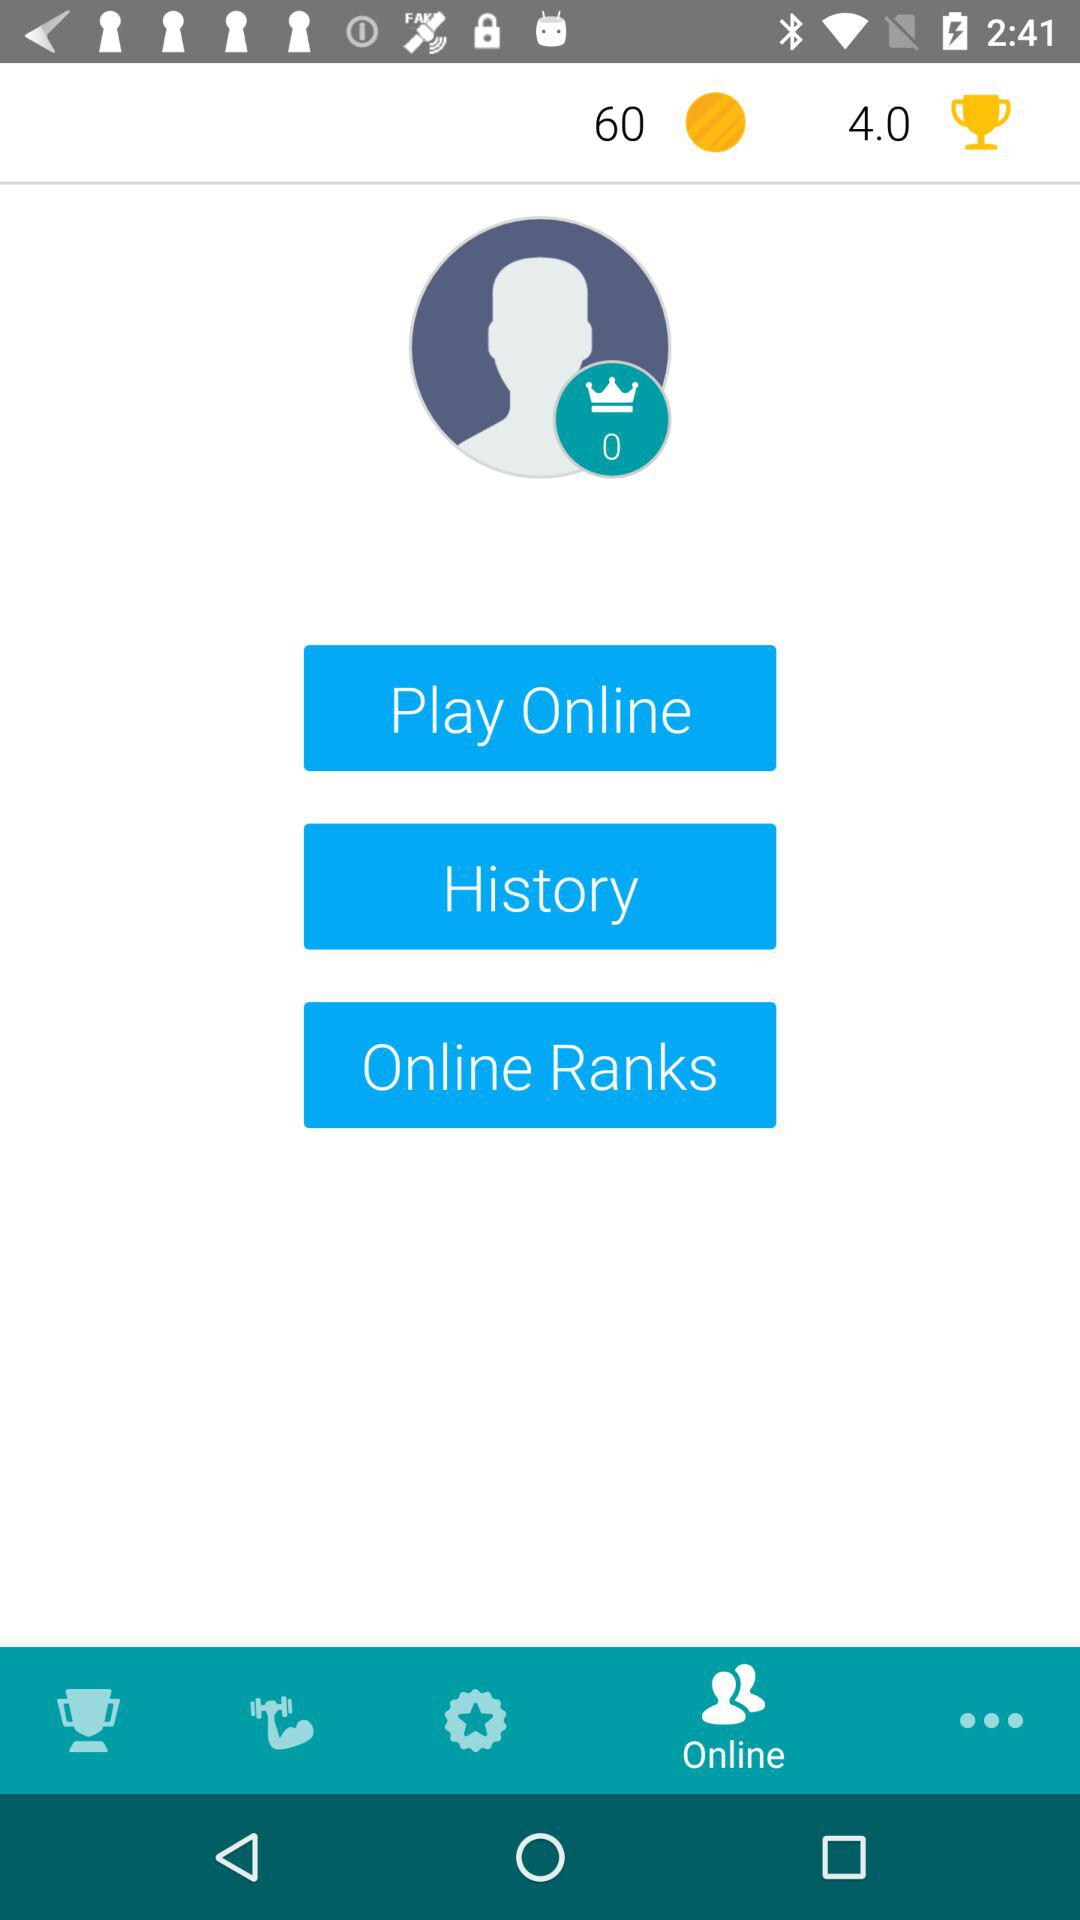What is the user's ranking?
When the provided information is insufficient, respond with <no answer>. <no answer> 